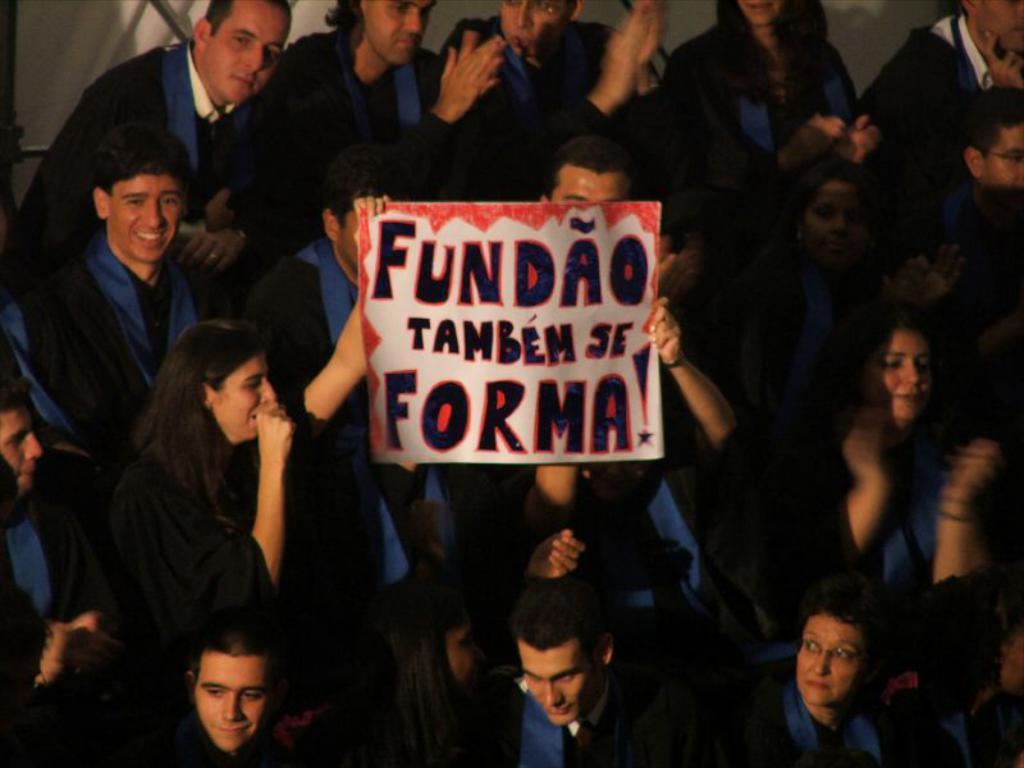How would you summarize this image in a sentence or two? In this image we can see these people wearing black coats are standing here and we can see a placard on which we can see some text is written. 